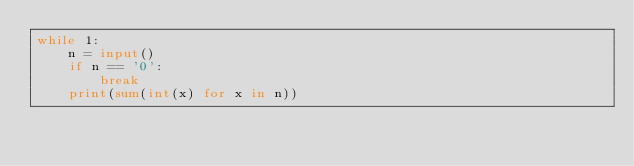<code> <loc_0><loc_0><loc_500><loc_500><_Python_>while 1:
    n = input()
    if n == '0':
        break
    print(sum(int(x) for x in n))
</code> 